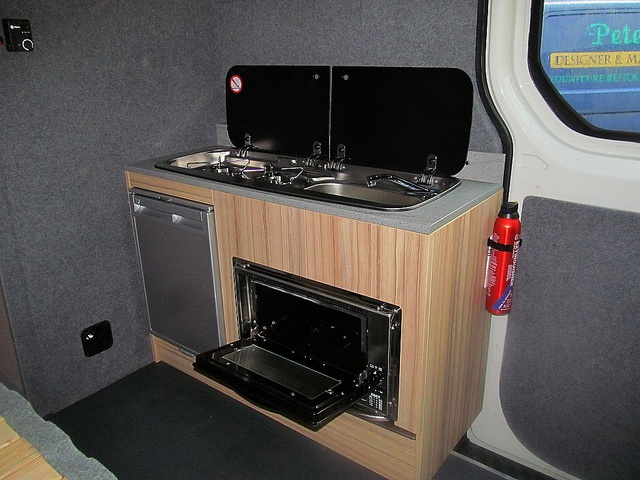Describe the objects in this image and their specific colors. I can see oven in black, gray, and darkgray tones, sink in black, gray, and darkgray tones, bottle in black, brown, red, and maroon tones, sink in black, darkgray, gray, and lightgray tones, and sink in black and gray tones in this image. 